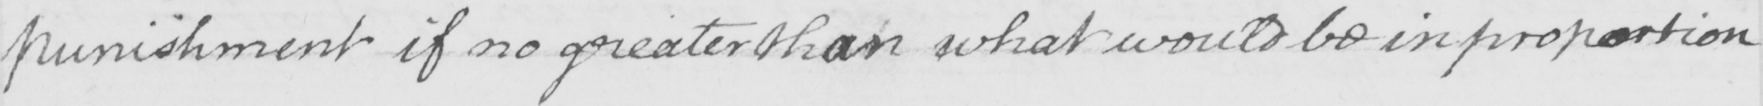What text is written in this handwritten line? punishment if no greater than what would be in proportion 